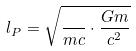Convert formula to latex. <formula><loc_0><loc_0><loc_500><loc_500>l _ { P } = \sqrt { \frac { } { m c } \cdot \frac { G m } { c ^ { 2 } } }</formula> 